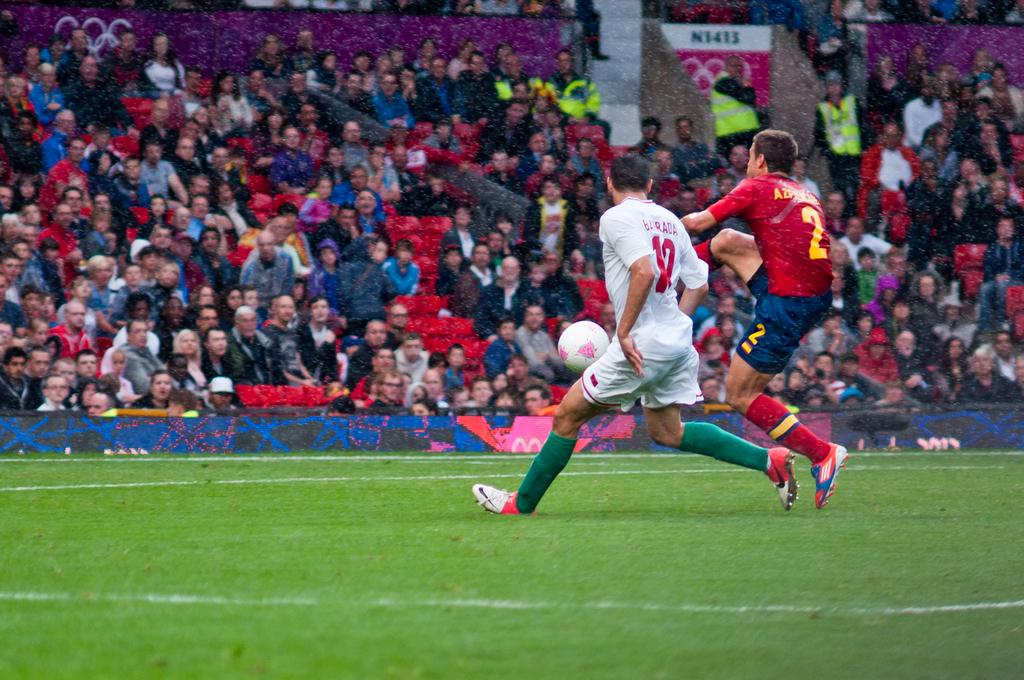What are the two persons in the foreground doing? The two persons in the foreground are playing football. Where is the football game taking place? The football game is taking place on the ground. What can be seen in the background of the image? There is a crowd and a fence in the background. Are there any other objects visible in the background? Yes, there are boards in the background. What type of toy is the doctor using to treat the injured player in the image? There is no doctor or injured player present in the image, and therefore no such treatment or toy can be observed. 